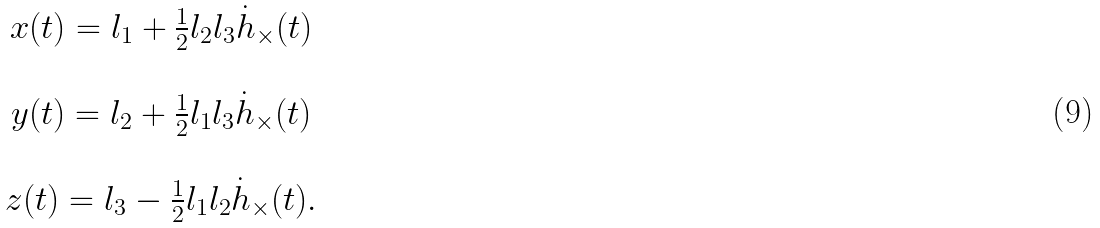Convert formula to latex. <formula><loc_0><loc_0><loc_500><loc_500>\begin{array} { c } x ( t ) = l _ { 1 } + \frac { 1 } { 2 } l _ { 2 } l _ { 3 } \dot { h } _ { \times } ( t ) \\ \\ y ( t ) = l _ { 2 } + \frac { 1 } { 2 } l _ { 1 } l _ { 3 } \dot { h } _ { \times } ( t ) \\ \\ z ( t ) = l _ { 3 } - \frac { 1 } { 2 } l _ { 1 } l _ { 2 } \dot { h } _ { \times } ( t ) . \end{array}</formula> 